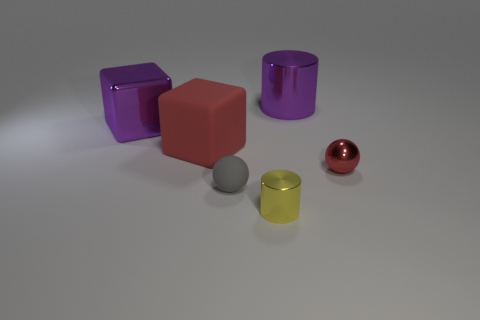There is a small object that is right of the big purple thing that is right of the small gray ball; what color is it?
Provide a short and direct response. Red. Is the material of the yellow thing the same as the red thing left of the tiny gray rubber sphere?
Offer a very short reply. No. What material is the cylinder that is in front of the small red metallic object?
Your answer should be compact. Metal. Is the number of large purple metallic cylinders in front of the matte cube the same as the number of big red rubber blocks?
Your answer should be compact. No. There is a sphere on the left side of the big cylinder behind the tiny rubber ball; what is its material?
Your answer should be compact. Rubber. There is a tiny thing that is on the right side of the tiny gray thing and left of the red ball; what shape is it?
Your answer should be compact. Cylinder. What size is the purple thing that is the same shape as the yellow thing?
Your response must be concise. Large. Are there fewer purple cylinders that are in front of the purple metallic cube than large matte balls?
Provide a short and direct response. No. There is a purple thing on the right side of the yellow cylinder; what size is it?
Your response must be concise. Large. There is another object that is the same shape as the big matte thing; what is its color?
Ensure brevity in your answer.  Purple. 